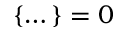<formula> <loc_0><loc_0><loc_500><loc_500>\left \{ \dots \right \} = 0</formula> 